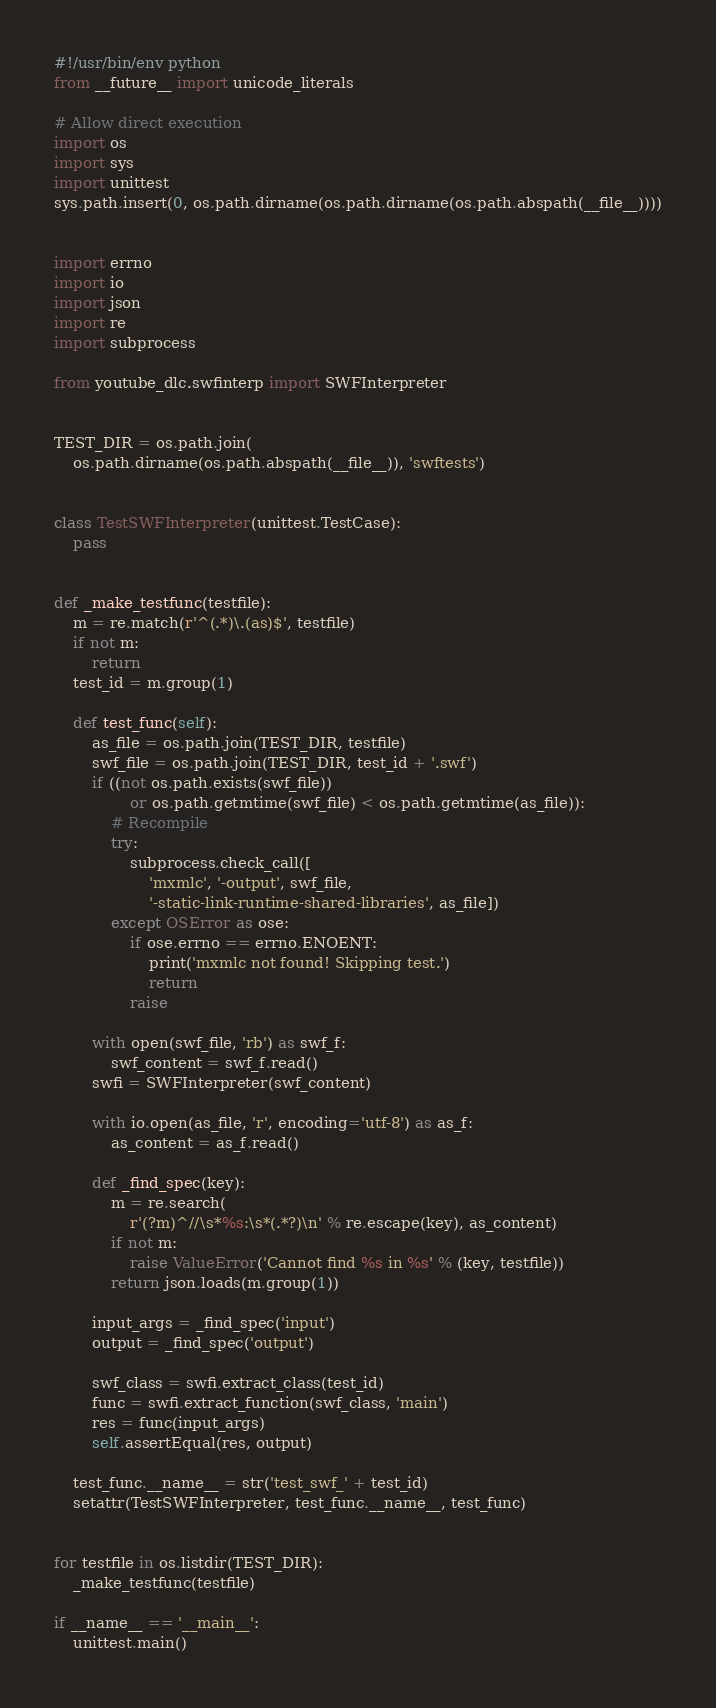<code> <loc_0><loc_0><loc_500><loc_500><_Python_>#!/usr/bin/env python
from __future__ import unicode_literals

# Allow direct execution
import os
import sys
import unittest
sys.path.insert(0, os.path.dirname(os.path.dirname(os.path.abspath(__file__))))


import errno
import io
import json
import re
import subprocess

from youtube_dlc.swfinterp import SWFInterpreter


TEST_DIR = os.path.join(
    os.path.dirname(os.path.abspath(__file__)), 'swftests')


class TestSWFInterpreter(unittest.TestCase):
    pass


def _make_testfunc(testfile):
    m = re.match(r'^(.*)\.(as)$', testfile)
    if not m:
        return
    test_id = m.group(1)

    def test_func(self):
        as_file = os.path.join(TEST_DIR, testfile)
        swf_file = os.path.join(TEST_DIR, test_id + '.swf')
        if ((not os.path.exists(swf_file))
                or os.path.getmtime(swf_file) < os.path.getmtime(as_file)):
            # Recompile
            try:
                subprocess.check_call([
                    'mxmlc', '-output', swf_file,
                    '-static-link-runtime-shared-libraries', as_file])
            except OSError as ose:
                if ose.errno == errno.ENOENT:
                    print('mxmlc not found! Skipping test.')
                    return
                raise

        with open(swf_file, 'rb') as swf_f:
            swf_content = swf_f.read()
        swfi = SWFInterpreter(swf_content)

        with io.open(as_file, 'r', encoding='utf-8') as as_f:
            as_content = as_f.read()

        def _find_spec(key):
            m = re.search(
                r'(?m)^//\s*%s:\s*(.*?)\n' % re.escape(key), as_content)
            if not m:
                raise ValueError('Cannot find %s in %s' % (key, testfile))
            return json.loads(m.group(1))

        input_args = _find_spec('input')
        output = _find_spec('output')

        swf_class = swfi.extract_class(test_id)
        func = swfi.extract_function(swf_class, 'main')
        res = func(input_args)
        self.assertEqual(res, output)

    test_func.__name__ = str('test_swf_' + test_id)
    setattr(TestSWFInterpreter, test_func.__name__, test_func)


for testfile in os.listdir(TEST_DIR):
    _make_testfunc(testfile)

if __name__ == '__main__':
    unittest.main()
</code> 